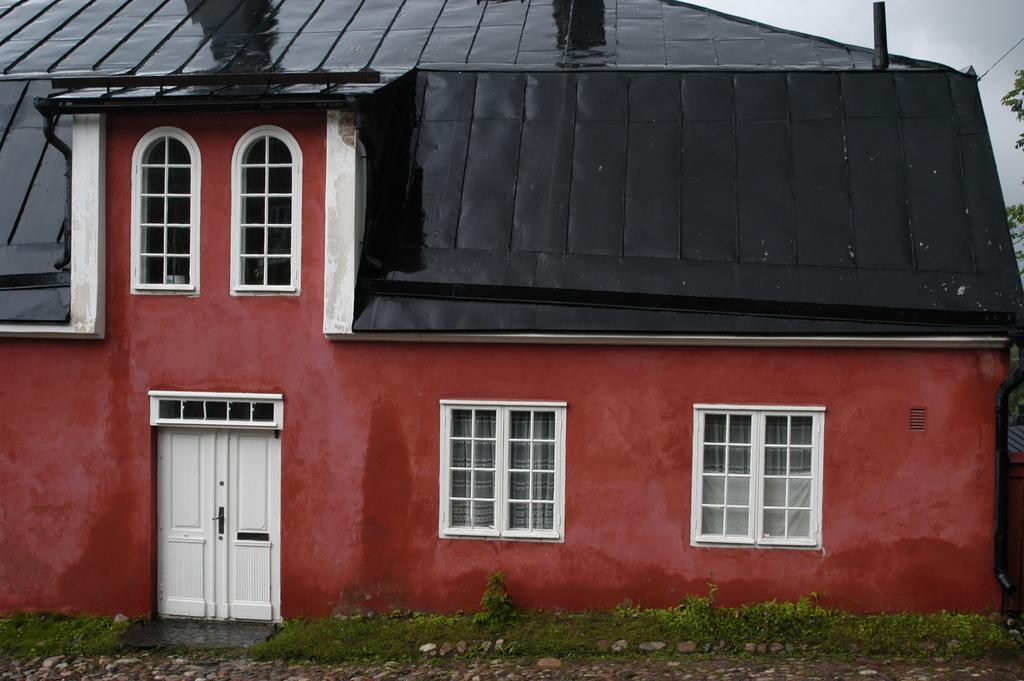How would you summarize this image in a sentence or two? In this picture we can observe a maroon color house. There is a black color roof. We can observe white color doors and windows. There are some plants. In the background there is a sky. 